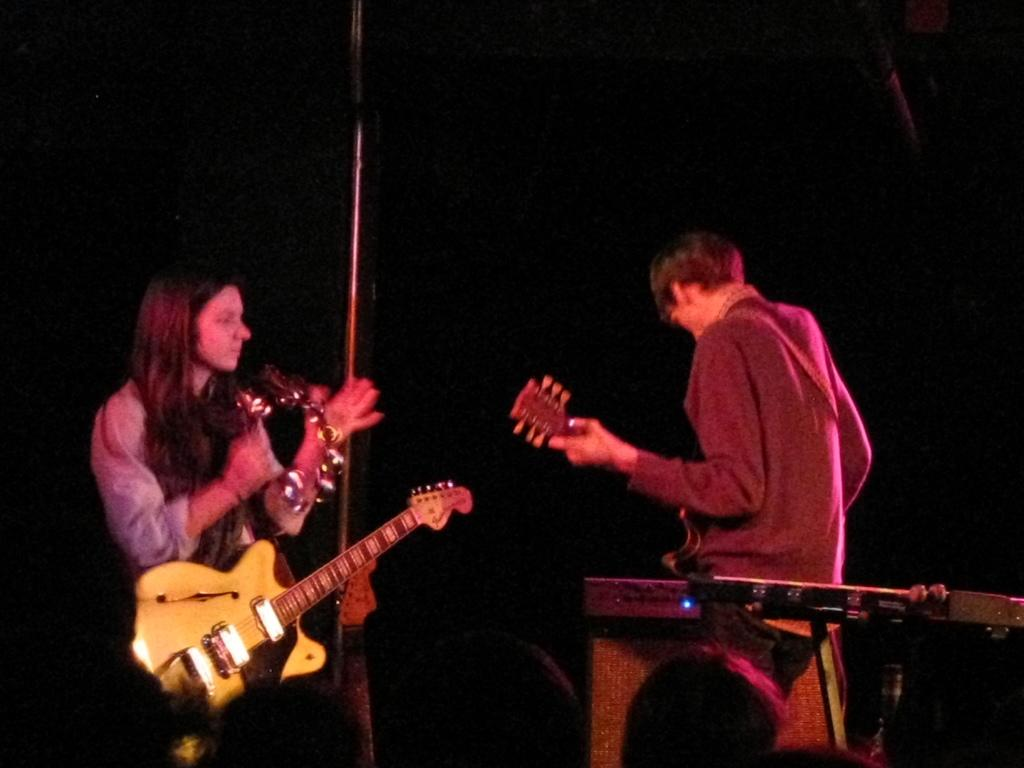What is the main subject of the image? The main subjects of the image are a woman and a man. What is the woman doing in the image? The woman is standing and playing a tambourine. What is the man doing in the image? The man is standing and playing a guitar. What is the woman wearing in the image? The woman is wearing a guitar. What type of organization is depicted in the image? There is no organization depicted in the image; it features a woman and a man playing musical instruments. What color is the sky in the image? The provided facts do not mention the sky or its color, so it cannot be determined from the image. 